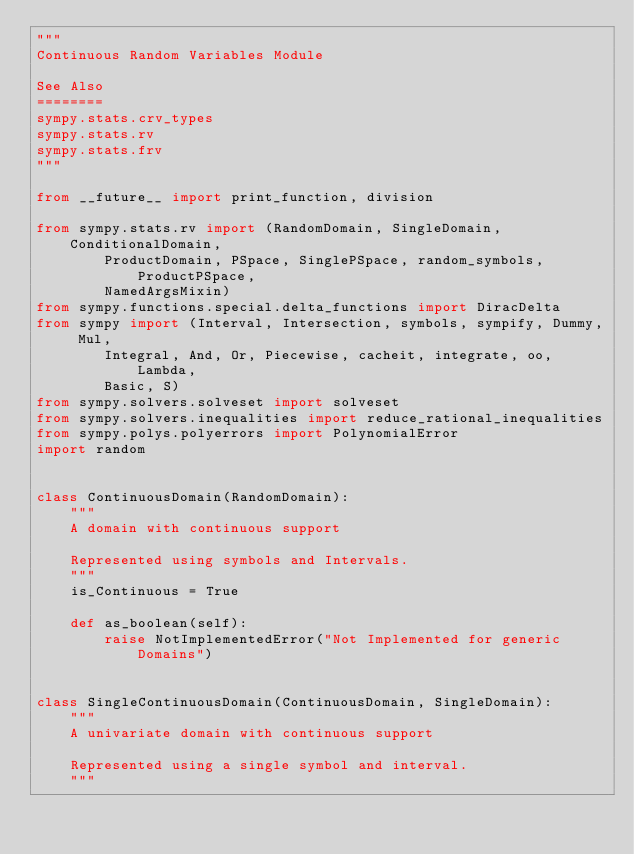<code> <loc_0><loc_0><loc_500><loc_500><_Python_>"""
Continuous Random Variables Module

See Also
========
sympy.stats.crv_types
sympy.stats.rv
sympy.stats.frv
"""

from __future__ import print_function, division

from sympy.stats.rv import (RandomDomain, SingleDomain, ConditionalDomain,
        ProductDomain, PSpace, SinglePSpace, random_symbols, ProductPSpace,
        NamedArgsMixin)
from sympy.functions.special.delta_functions import DiracDelta
from sympy import (Interval, Intersection, symbols, sympify, Dummy, Mul,
        Integral, And, Or, Piecewise, cacheit, integrate, oo, Lambda,
        Basic, S)
from sympy.solvers.solveset import solveset
from sympy.solvers.inequalities import reduce_rational_inequalities
from sympy.polys.polyerrors import PolynomialError
import random


class ContinuousDomain(RandomDomain):
    """
    A domain with continuous support

    Represented using symbols and Intervals.
    """
    is_Continuous = True

    def as_boolean(self):
        raise NotImplementedError("Not Implemented for generic Domains")


class SingleContinuousDomain(ContinuousDomain, SingleDomain):
    """
    A univariate domain with continuous support

    Represented using a single symbol and interval.
    """</code> 